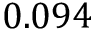<formula> <loc_0><loc_0><loc_500><loc_500>0 . 0 9 4</formula> 